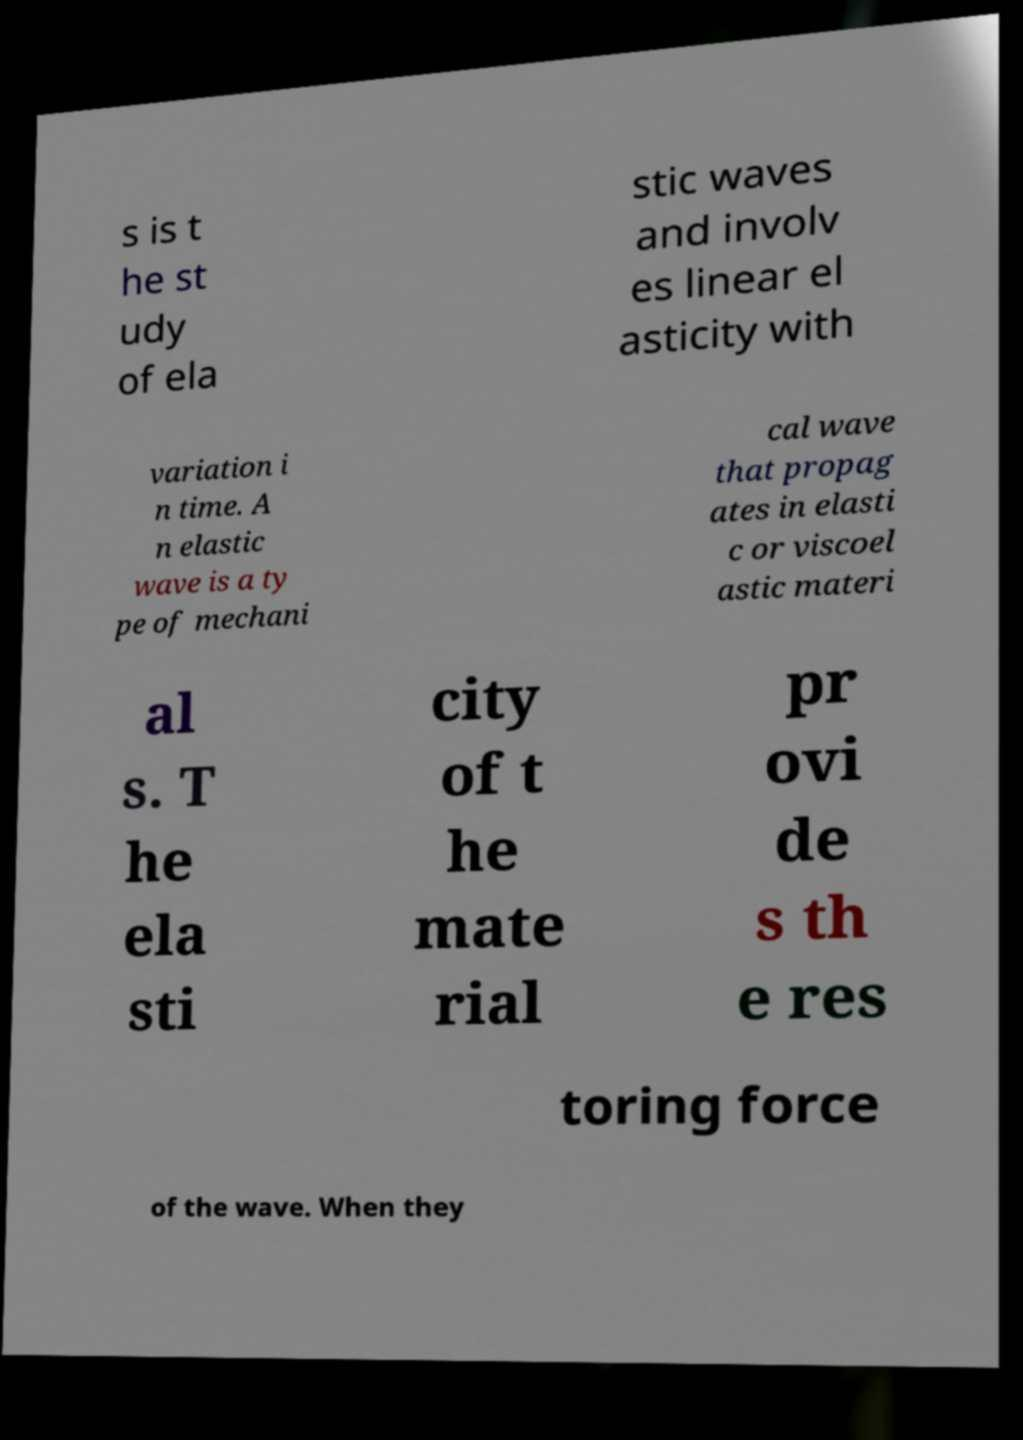What messages or text are displayed in this image? I need them in a readable, typed format. s is t he st udy of ela stic waves and involv es linear el asticity with variation i n time. A n elastic wave is a ty pe of mechani cal wave that propag ates in elasti c or viscoel astic materi al s. T he ela sti city of t he mate rial pr ovi de s th e res toring force of the wave. When they 